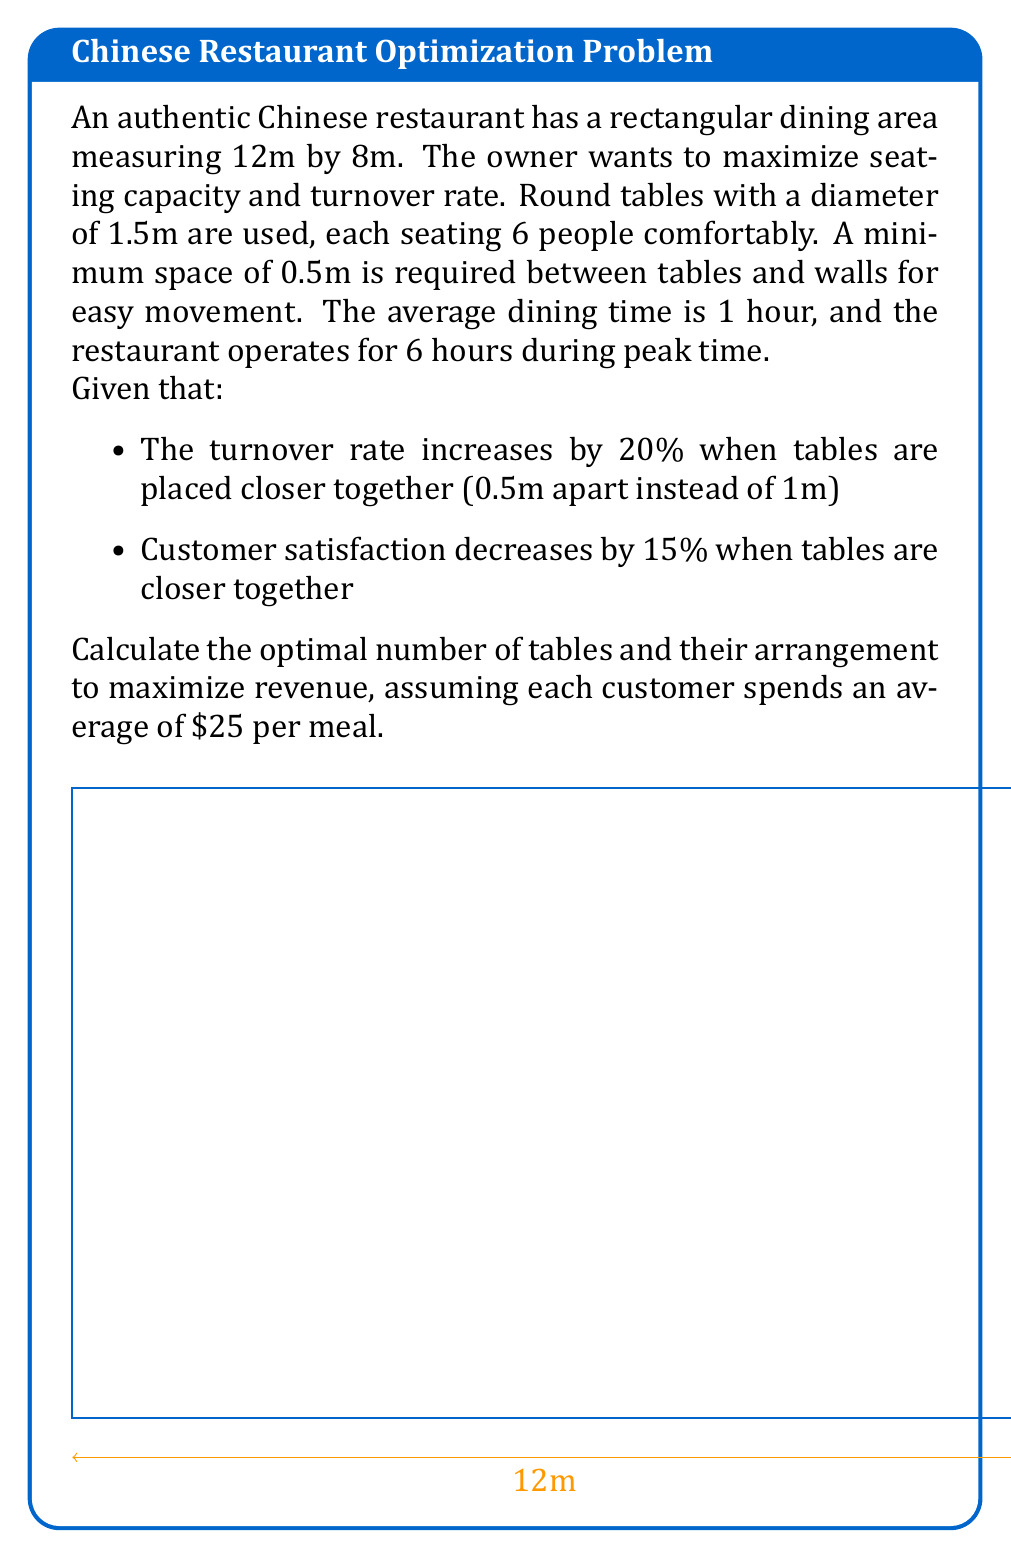Give your solution to this math problem. Let's approach this problem step-by-step:

1) First, calculate the usable area:
   Usable length = 12m - (2 * 0.5m) = 11m
   Usable width = 8m - (2 * 0.5m) = 7m

2) Calculate the number of tables that can fit:
   For 1m spacing:
   Tables along length = floor(11 / 2.5) = 4
   Tables along width = floor(7 / 2.5) = 2
   Total tables = 4 * 2 = 8

   For 0.5m spacing:
   Tables along length = floor(11 / 2) = 5
   Tables along width = floor(7 / 2) = 3
   Total tables = 5 * 3 = 15

3) Calculate customer capacity:
   1m spacing: 8 * 6 = 48 customers
   0.5m spacing: 15 * 6 = 90 customers

4) Calculate turnover during peak hours:
   1m spacing: 48 * 6 = 288 customers
   0.5m spacing: 90 * 6 * 1.2 = 648 customers (including 20% increase)

5) Calculate revenue:
   1m spacing: 288 * $25 = $7,200
   0.5m spacing: 648 * $25 * 0.85 = $13,770 (factoring in 15% decrease in satisfaction)

The 0.5m spacing arrangement generates more revenue despite the decrease in customer satisfaction.
Answer: 15 tables arranged with 0.5m spacing, generating $13,770 in revenue. 